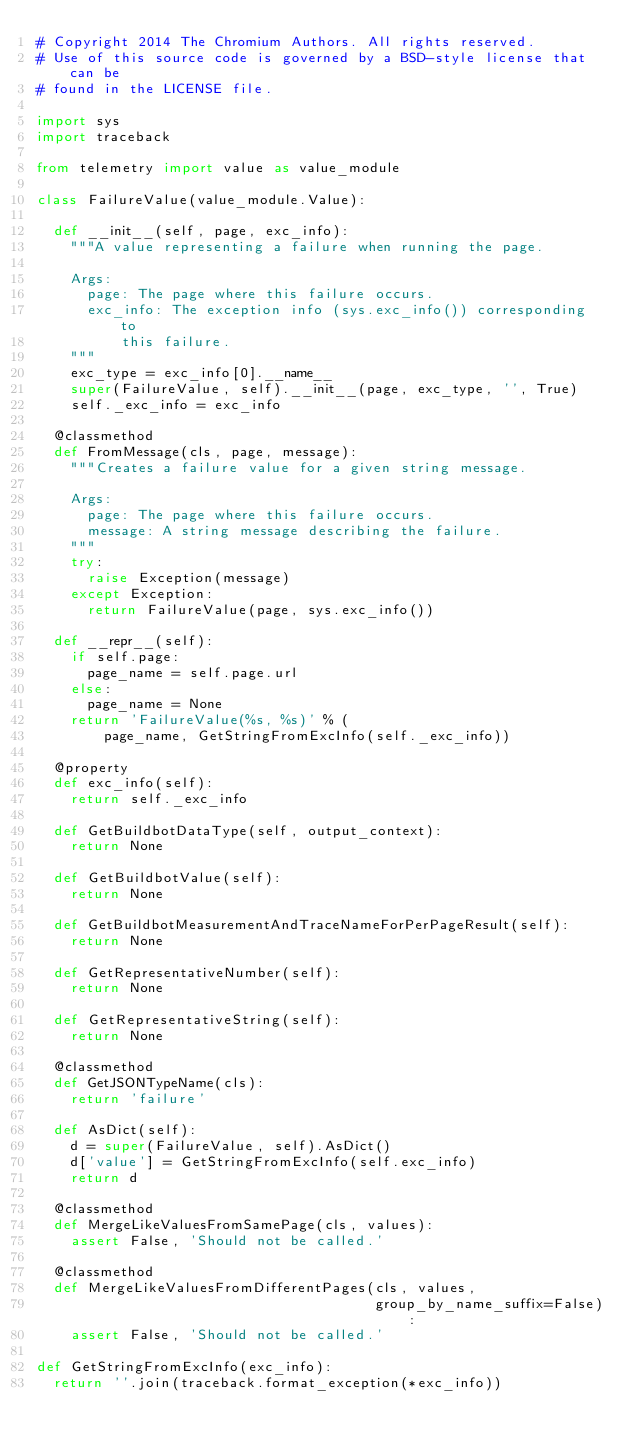<code> <loc_0><loc_0><loc_500><loc_500><_Python_># Copyright 2014 The Chromium Authors. All rights reserved.
# Use of this source code is governed by a BSD-style license that can be
# found in the LICENSE file.

import sys
import traceback

from telemetry import value as value_module

class FailureValue(value_module.Value):

  def __init__(self, page, exc_info):
    """A value representing a failure when running the page.

    Args:
      page: The page where this failure occurs.
      exc_info: The exception info (sys.exc_info()) corresponding to
          this failure.
    """
    exc_type = exc_info[0].__name__
    super(FailureValue, self).__init__(page, exc_type, '', True)
    self._exc_info = exc_info

  @classmethod
  def FromMessage(cls, page, message):
    """Creates a failure value for a given string message.

    Args:
      page: The page where this failure occurs.
      message: A string message describing the failure.
    """
    try:
      raise Exception(message)
    except Exception:
      return FailureValue(page, sys.exc_info())

  def __repr__(self):
    if self.page:
      page_name = self.page.url
    else:
      page_name = None
    return 'FailureValue(%s, %s)' % (
        page_name, GetStringFromExcInfo(self._exc_info))

  @property
  def exc_info(self):
    return self._exc_info

  def GetBuildbotDataType(self, output_context):
    return None

  def GetBuildbotValue(self):
    return None

  def GetBuildbotMeasurementAndTraceNameForPerPageResult(self):
    return None

  def GetRepresentativeNumber(self):
    return None

  def GetRepresentativeString(self):
    return None

  @classmethod
  def GetJSONTypeName(cls):
    return 'failure'

  def AsDict(self):
    d = super(FailureValue, self).AsDict()
    d['value'] = GetStringFromExcInfo(self.exc_info)
    return d

  @classmethod
  def MergeLikeValuesFromSamePage(cls, values):
    assert False, 'Should not be called.'

  @classmethod
  def MergeLikeValuesFromDifferentPages(cls, values,
                                        group_by_name_suffix=False):
    assert False, 'Should not be called.'

def GetStringFromExcInfo(exc_info):
  return ''.join(traceback.format_exception(*exc_info))
</code> 